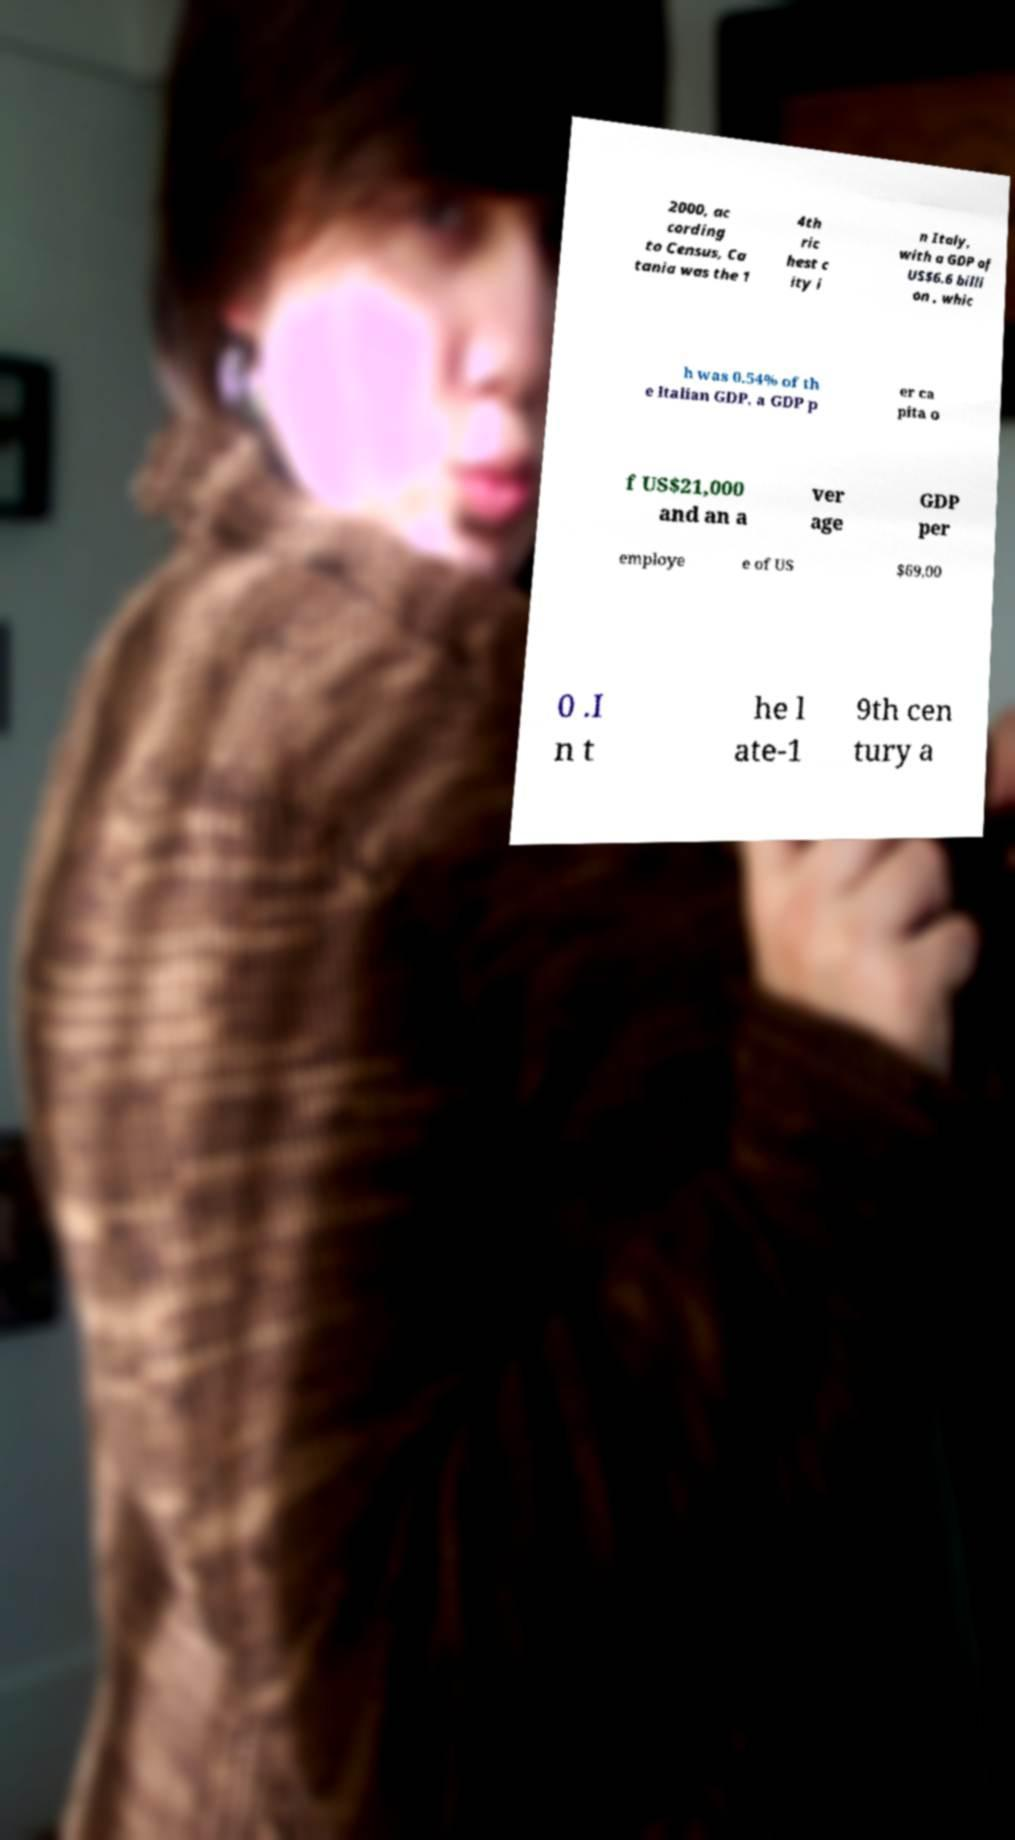There's text embedded in this image that I need extracted. Can you transcribe it verbatim? 2000, ac cording to Census, Ca tania was the 1 4th ric hest c ity i n Italy, with a GDP of US$6.6 billi on , whic h was 0.54% of th e Italian GDP, a GDP p er ca pita o f US$21,000 and an a ver age GDP per employe e of US $69,00 0 .I n t he l ate-1 9th cen tury a 